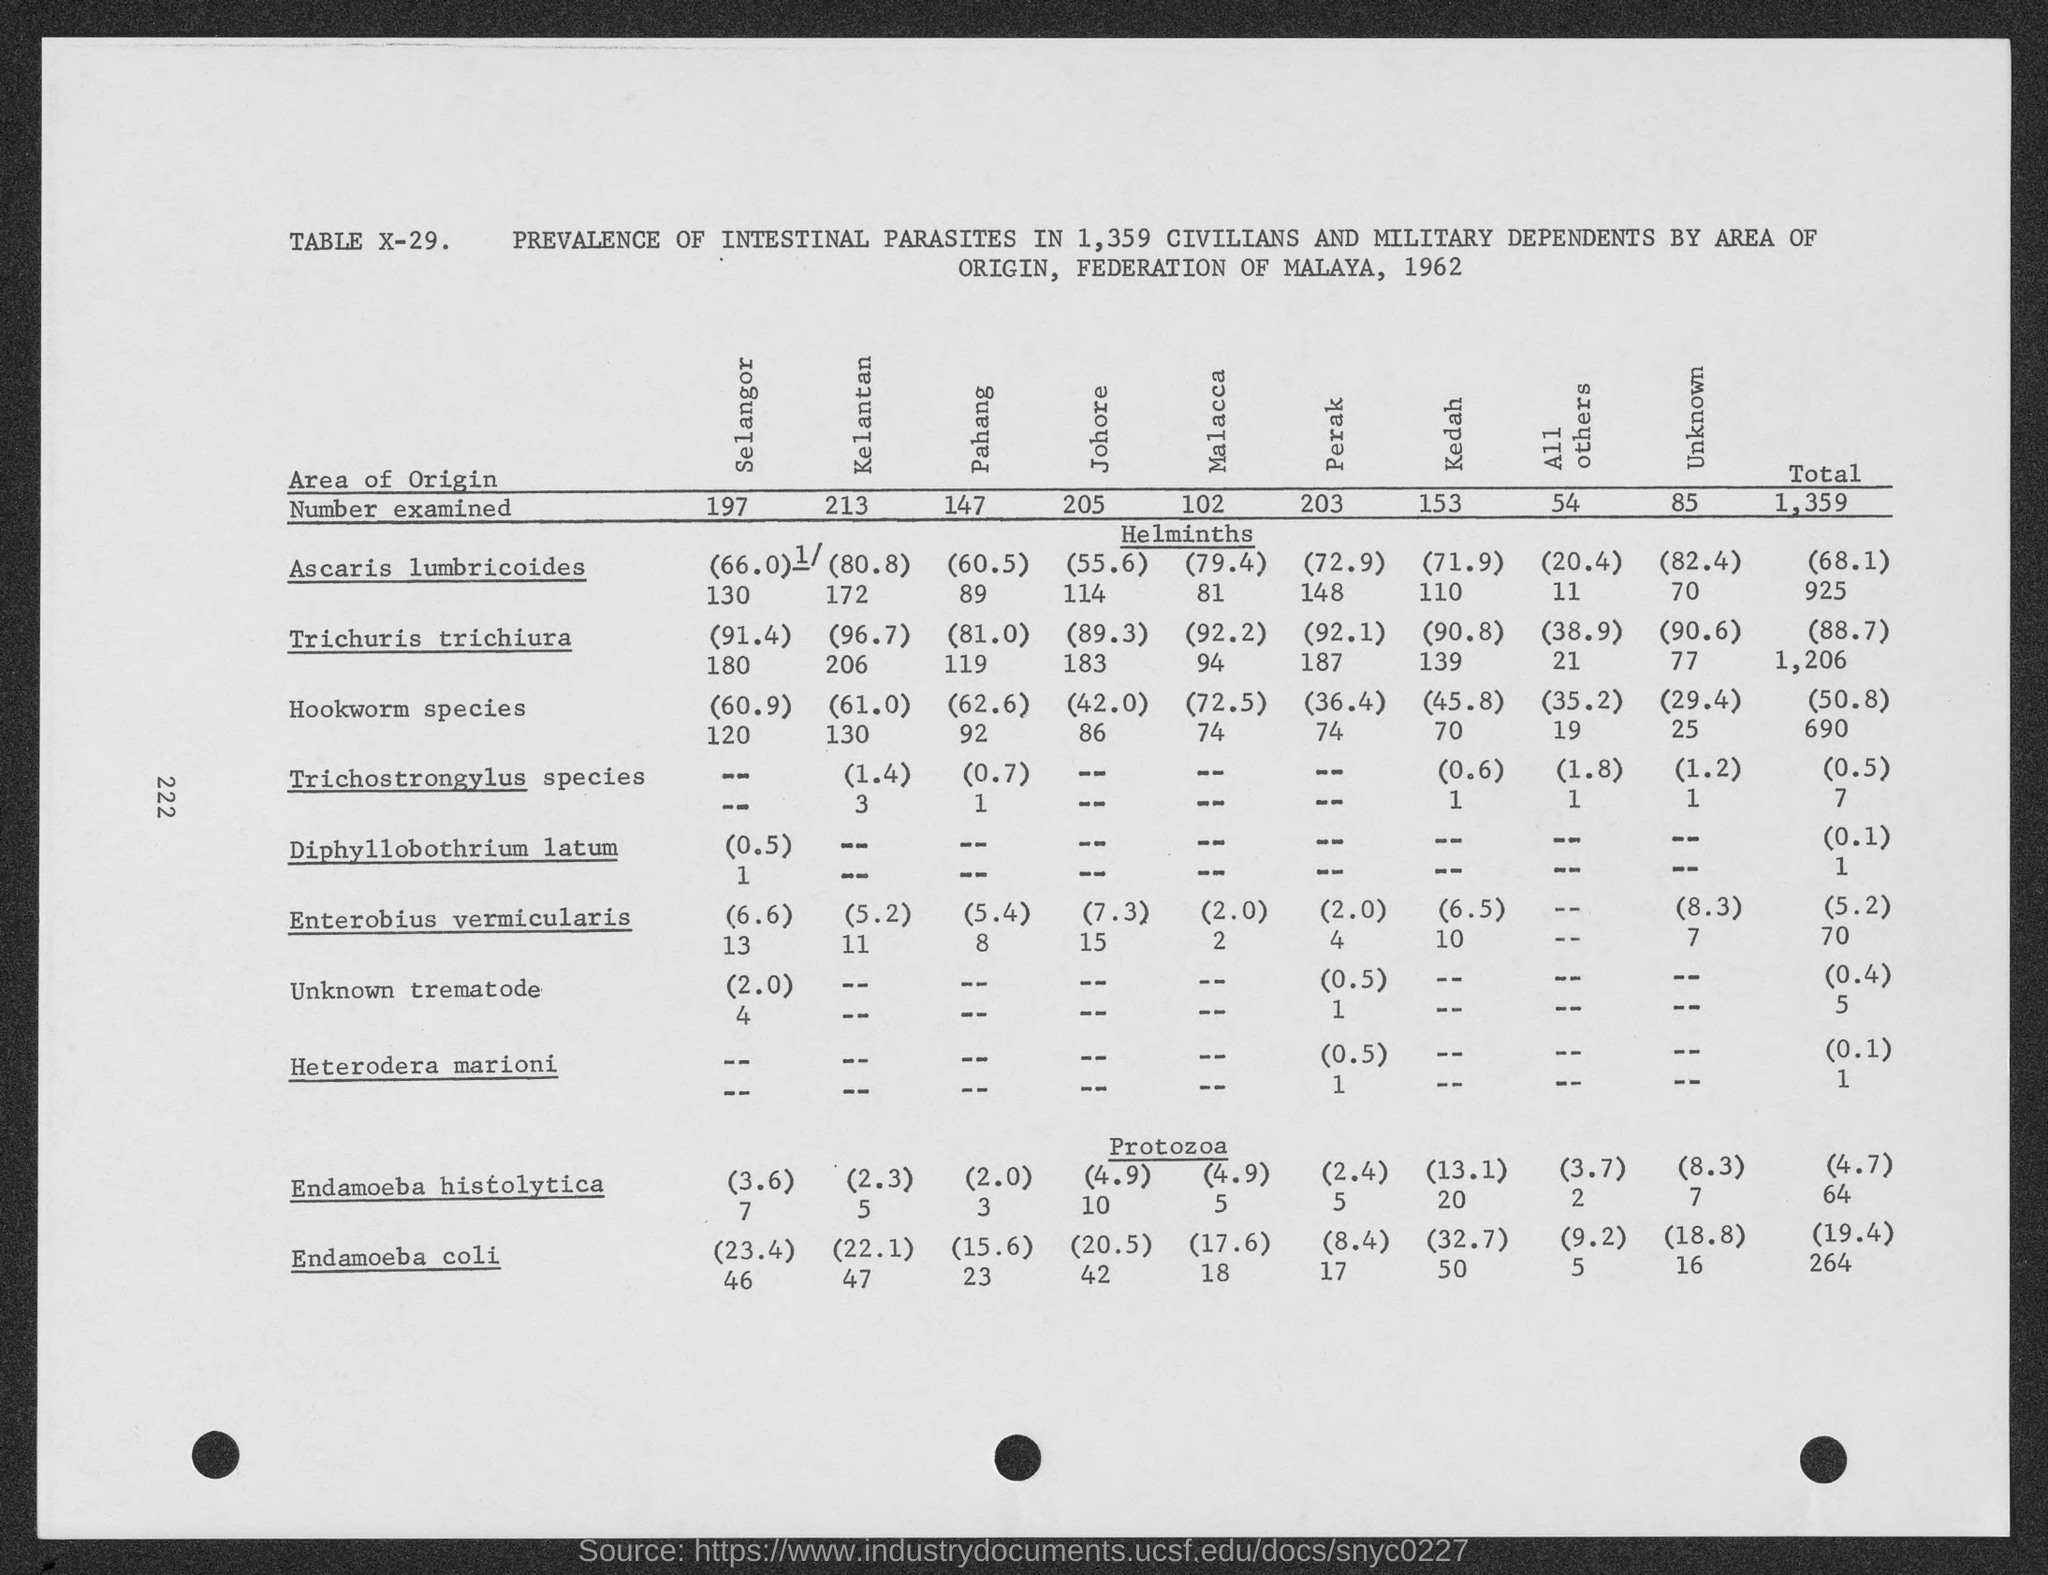Which parasite has the highest prevalence according to this data? The parasite with the highest occurrence in this data is Trichuris trichiura, also known as whipworm. The total column on the far right shows that it was found in 925 cases out of the 1,359 individuals examined, making it the most prevalent intestinal parasite reported in this table. 